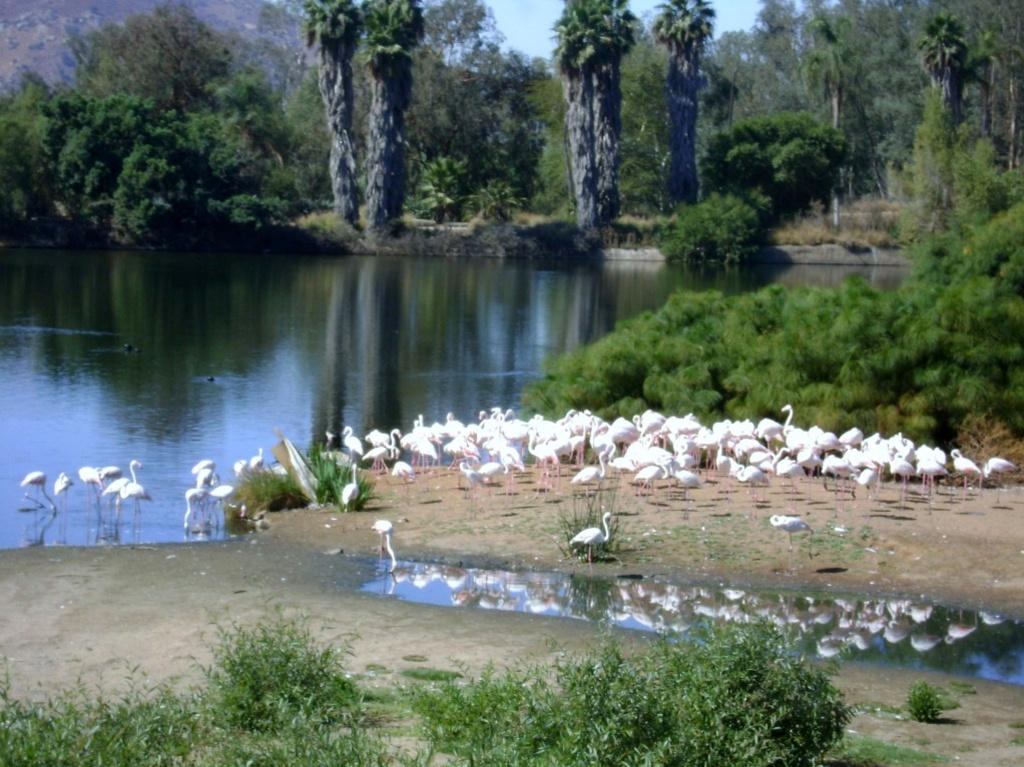What type of animals can be seen in the image? There are many ducks in the image. Where are the ducks located in the image? Some ducks are on the ground, while others are on the water. What is visible in the image besides the ducks? There is water visible in the image, and trees can be seen in the background. What type of stone is being used to wage war in the image? There is no reference to stone or war in the image; it features ducks in a water setting with trees in the background. 